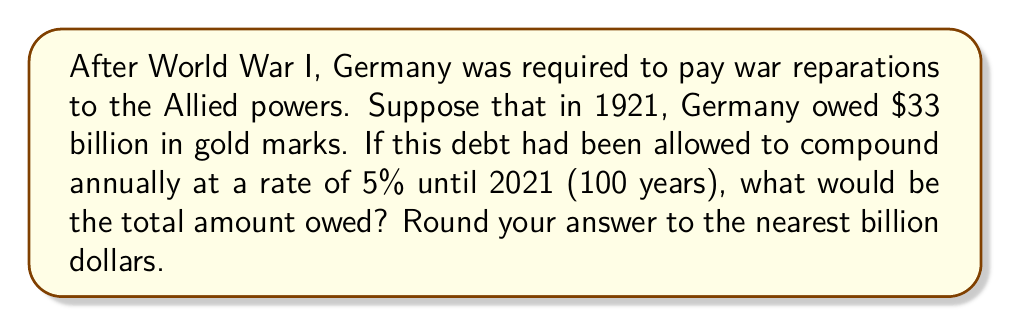Solve this math problem. To solve this problem, we need to use the compound interest formula:

$$A = P(1 + r)^n$$

Where:
$A$ = Final amount
$P$ = Principal (initial amount)
$r$ = Annual interest rate (as a decimal)
$n$ = Number of years

Given:
$P = 33$ billion gold marks
$r = 0.05$ (5% written as a decimal)
$n = 100$ years

Let's substitute these values into the formula:

$$A = 33(1 + 0.05)^{100}$$

Now, let's calculate step by step:

1) First, calculate $(1 + 0.05)^{100}$:
   $$(1.05)^{100} \approx 131.50$$

2) Multiply this by the principal:
   $$33 \times 131.50 \approx 4,339.50$$

Therefore, after 100 years of compound interest at 5% annually, the 33 billion gold marks would grow to approximately 4,339.50 billion gold marks.

Rounding to the nearest billion as requested in the question, we get 4,340 billion gold marks.
Answer: $4,340 billion gold marks 